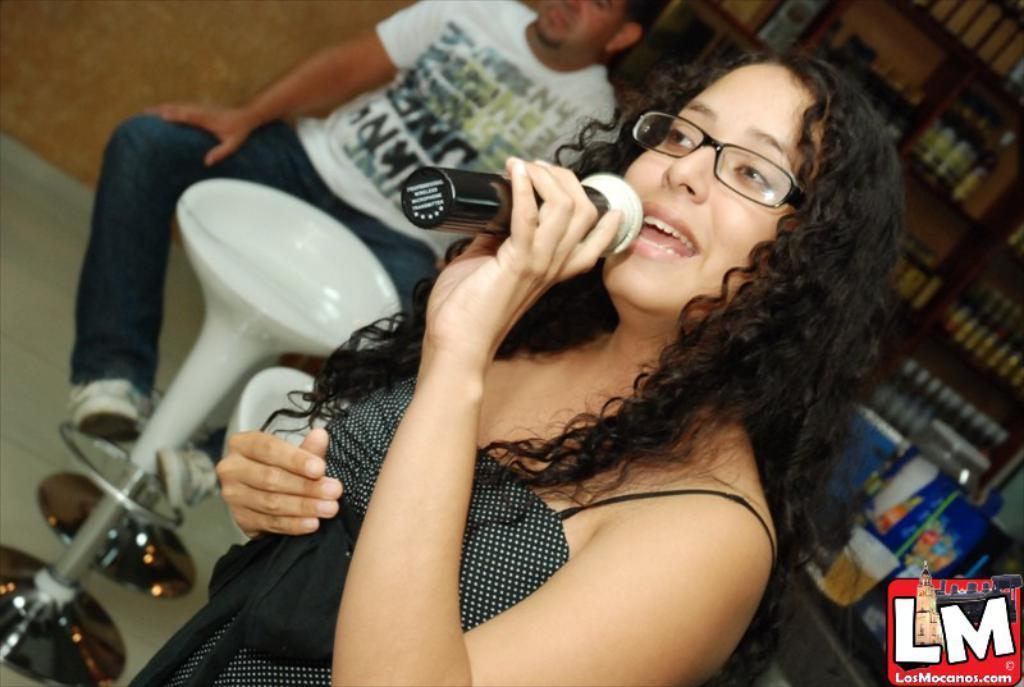Describe this image in one or two sentences. In this picture we can see a woman is holding a microphone and speaking something, on the right side there is a rack, we can see some bottles on the rack, at the right bottom there is a table and a logo, we can see a glass of drink on the table, we can see a chair and another person in the background. 